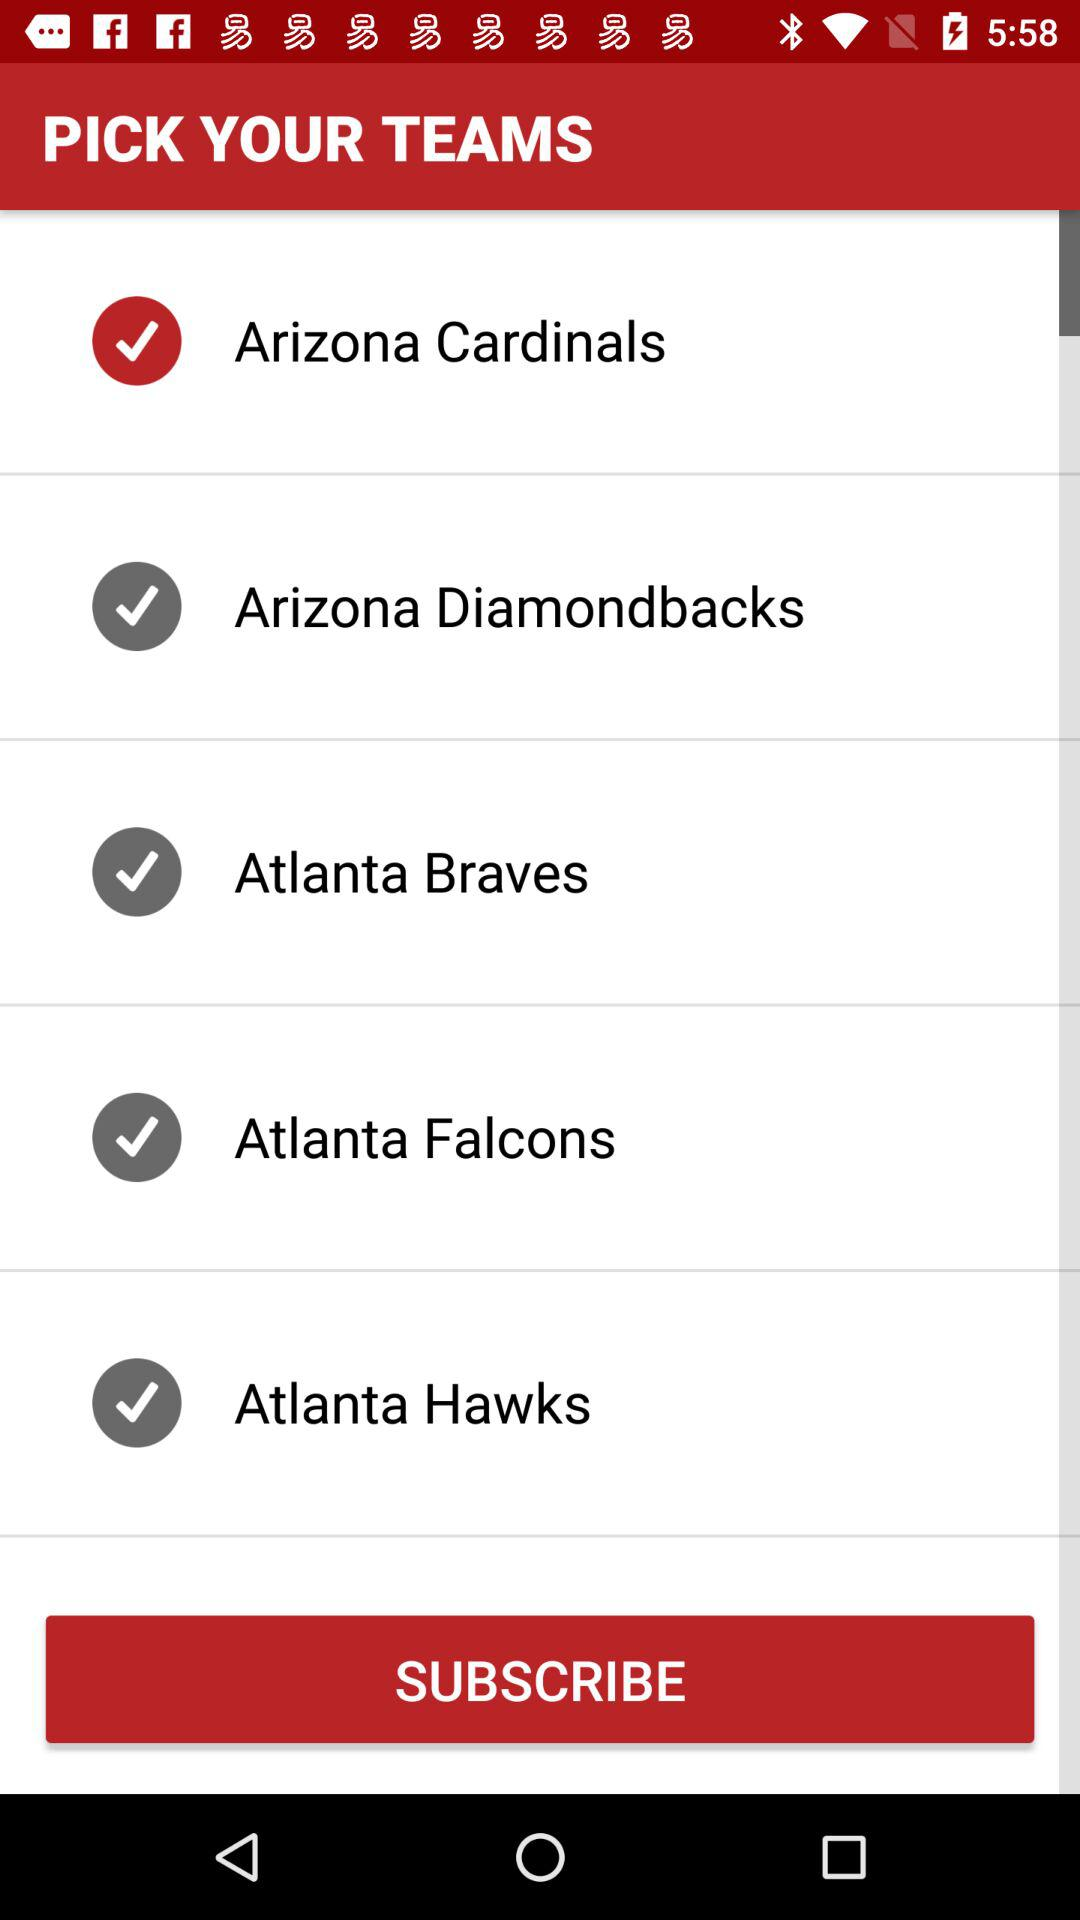What is the selected team? The selected team is "Arizona Cardinals". 